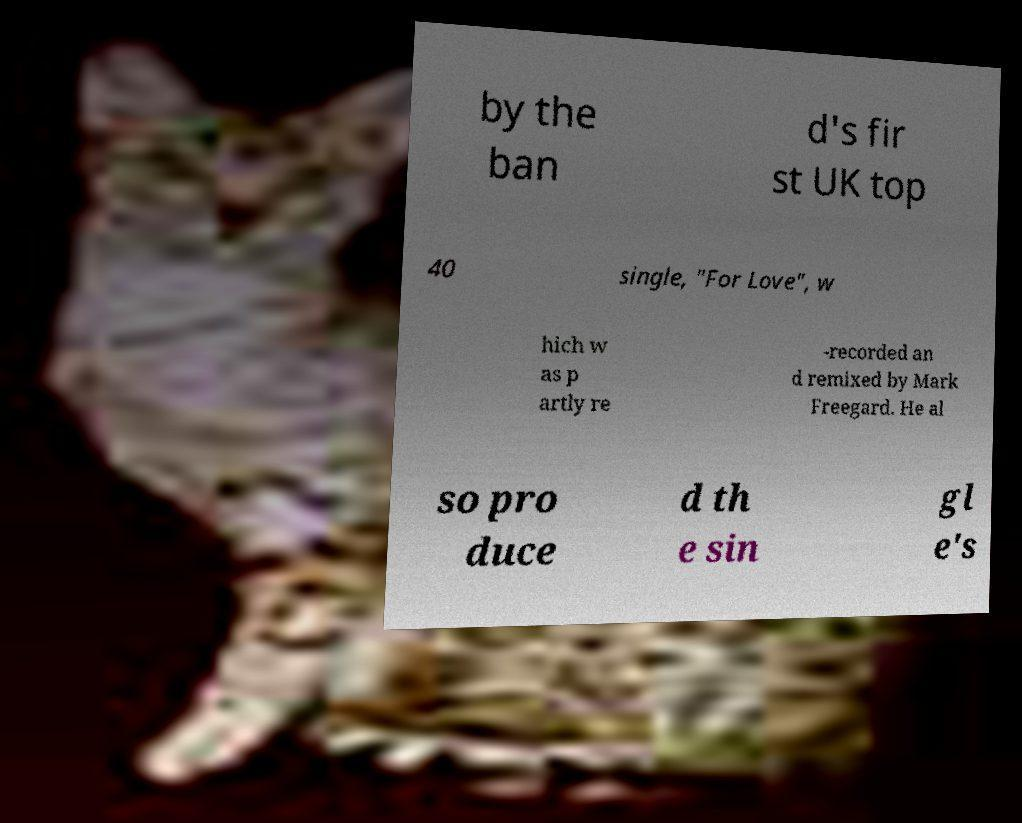There's text embedded in this image that I need extracted. Can you transcribe it verbatim? by the ban d's fir st UK top 40 single, "For Love", w hich w as p artly re -recorded an d remixed by Mark Freegard. He al so pro duce d th e sin gl e's 